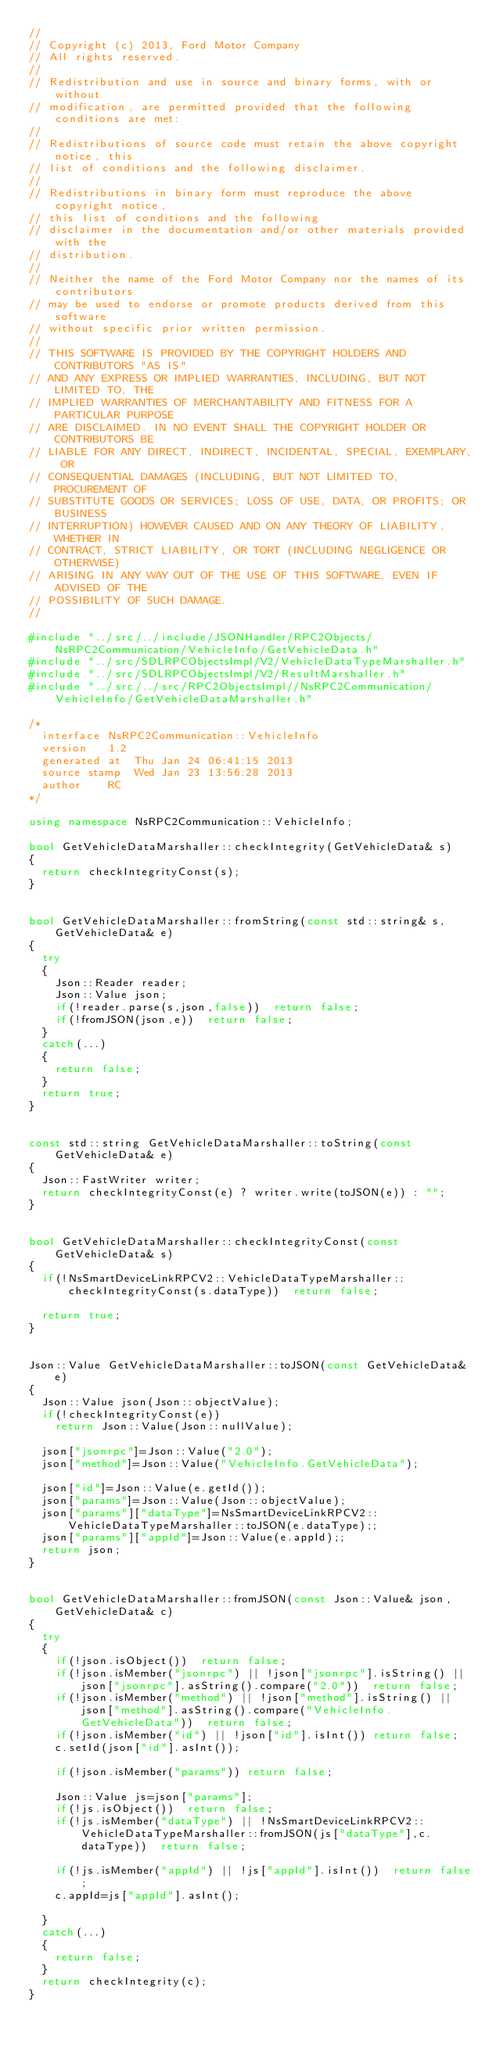Convert code to text. <code><loc_0><loc_0><loc_500><loc_500><_C++_>//
// Copyright (c) 2013, Ford Motor Company
// All rights reserved.
//
// Redistribution and use in source and binary forms, with or without
// modification, are permitted provided that the following conditions are met:
//
// Redistributions of source code must retain the above copyright notice, this
// list of conditions and the following disclaimer.
//
// Redistributions in binary form must reproduce the above copyright notice,
// this list of conditions and the following
// disclaimer in the documentation and/or other materials provided with the
// distribution.
//
// Neither the name of the Ford Motor Company nor the names of its contributors
// may be used to endorse or promote products derived from this software
// without specific prior written permission.
//
// THIS SOFTWARE IS PROVIDED BY THE COPYRIGHT HOLDERS AND CONTRIBUTORS "AS IS"
// AND ANY EXPRESS OR IMPLIED WARRANTIES, INCLUDING, BUT NOT LIMITED TO, THE
// IMPLIED WARRANTIES OF MERCHANTABILITY AND FITNESS FOR A PARTICULAR PURPOSE
// ARE DISCLAIMED. IN NO EVENT SHALL THE COPYRIGHT HOLDER OR CONTRIBUTORS BE
// LIABLE FOR ANY DIRECT, INDIRECT, INCIDENTAL, SPECIAL, EXEMPLARY, OR
// CONSEQUENTIAL DAMAGES (INCLUDING, BUT NOT LIMITED TO, PROCUREMENT OF
// SUBSTITUTE GOODS OR SERVICES; LOSS OF USE, DATA, OR PROFITS; OR BUSINESS
// INTERRUPTION) HOWEVER CAUSED AND ON ANY THEORY OF LIABILITY, WHETHER IN
// CONTRACT, STRICT LIABILITY, OR TORT (INCLUDING NEGLIGENCE OR OTHERWISE)
// ARISING IN ANY WAY OUT OF THE USE OF THIS SOFTWARE, EVEN IF ADVISED OF THE
// POSSIBILITY OF SUCH DAMAGE.
//

#include "../src/../include/JSONHandler/RPC2Objects/NsRPC2Communication/VehicleInfo/GetVehicleData.h"
#include "../src/SDLRPCObjectsImpl/V2/VehicleDataTypeMarshaller.h"
#include "../src/SDLRPCObjectsImpl/V2/ResultMarshaller.h"
#include "../src/../src/RPC2ObjectsImpl//NsRPC2Communication/VehicleInfo/GetVehicleDataMarshaller.h"

/*
  interface	NsRPC2Communication::VehicleInfo
  version	1.2
  generated at	Thu Jan 24 06:41:15 2013
  source stamp	Wed Jan 23 13:56:28 2013
  author	RC
*/

using namespace NsRPC2Communication::VehicleInfo;

bool GetVehicleDataMarshaller::checkIntegrity(GetVehicleData& s)
{
  return checkIntegrityConst(s);
}


bool GetVehicleDataMarshaller::fromString(const std::string& s,GetVehicleData& e)
{
  try
  {
    Json::Reader reader;
    Json::Value json;
    if(!reader.parse(s,json,false))  return false;
    if(!fromJSON(json,e))  return false;
  }
  catch(...)
  {
    return false;
  }
  return true;
}


const std::string GetVehicleDataMarshaller::toString(const GetVehicleData& e)
{
  Json::FastWriter writer;
  return checkIntegrityConst(e) ? writer.write(toJSON(e)) : "";
}


bool GetVehicleDataMarshaller::checkIntegrityConst(const GetVehicleData& s)
{
  if(!NsSmartDeviceLinkRPCV2::VehicleDataTypeMarshaller::checkIntegrityConst(s.dataType))  return false;

  return true;
}


Json::Value GetVehicleDataMarshaller::toJSON(const GetVehicleData& e)
{
  Json::Value json(Json::objectValue);
  if(!checkIntegrityConst(e))
    return Json::Value(Json::nullValue);

  json["jsonrpc"]=Json::Value("2.0");
  json["method"]=Json::Value("VehicleInfo.GetVehicleData");

  json["id"]=Json::Value(e.getId());
  json["params"]=Json::Value(Json::objectValue);
  json["params"]["dataType"]=NsSmartDeviceLinkRPCV2::VehicleDataTypeMarshaller::toJSON(e.dataType);;
  json["params"]["appId"]=Json::Value(e.appId);;
  return json;
}


bool GetVehicleDataMarshaller::fromJSON(const Json::Value& json,GetVehicleData& c)
{
  try
  {
    if(!json.isObject())  return false;
    if(!json.isMember("jsonrpc") || !json["jsonrpc"].isString() || json["jsonrpc"].asString().compare("2.0"))  return false;
    if(!json.isMember("method") || !json["method"].isString() || json["method"].asString().compare("VehicleInfo.GetVehicleData"))  return false;
    if(!json.isMember("id") || !json["id"].isInt()) return false;
    c.setId(json["id"].asInt());

    if(!json.isMember("params")) return false;

    Json::Value js=json["params"];
    if(!js.isObject())  return false;
    if(!js.isMember("dataType") || !NsSmartDeviceLinkRPCV2::VehicleDataTypeMarshaller::fromJSON(js["dataType"],c.dataType))  return false;

    if(!js.isMember("appId") || !js["appId"].isInt())  return false;
    c.appId=js["appId"].asInt();
    
  }
  catch(...)
  {
    return false;
  }
  return checkIntegrity(c);
}
</code> 